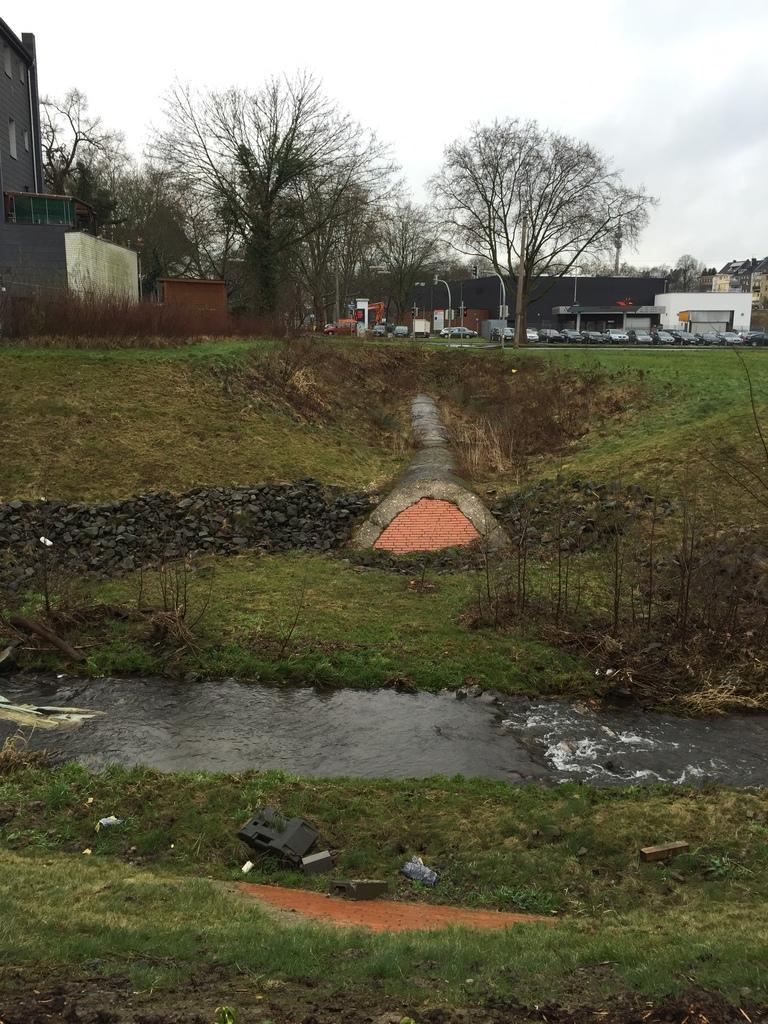What is happening in the image? There is water flow in the image. What type of vegetation can be seen in the image? There is grass, plants, and trees visible in the image. What objects are present in the image? There are objects, stones, houses, buildings, vehicles, and poles in the image. What is visible in the background of the image? The sky is visible in the background of the image. What type of knowledge is being shared among the plants in the image? There is no indication in the image that the plants are sharing knowledge or engaging in any form of communication. --- 